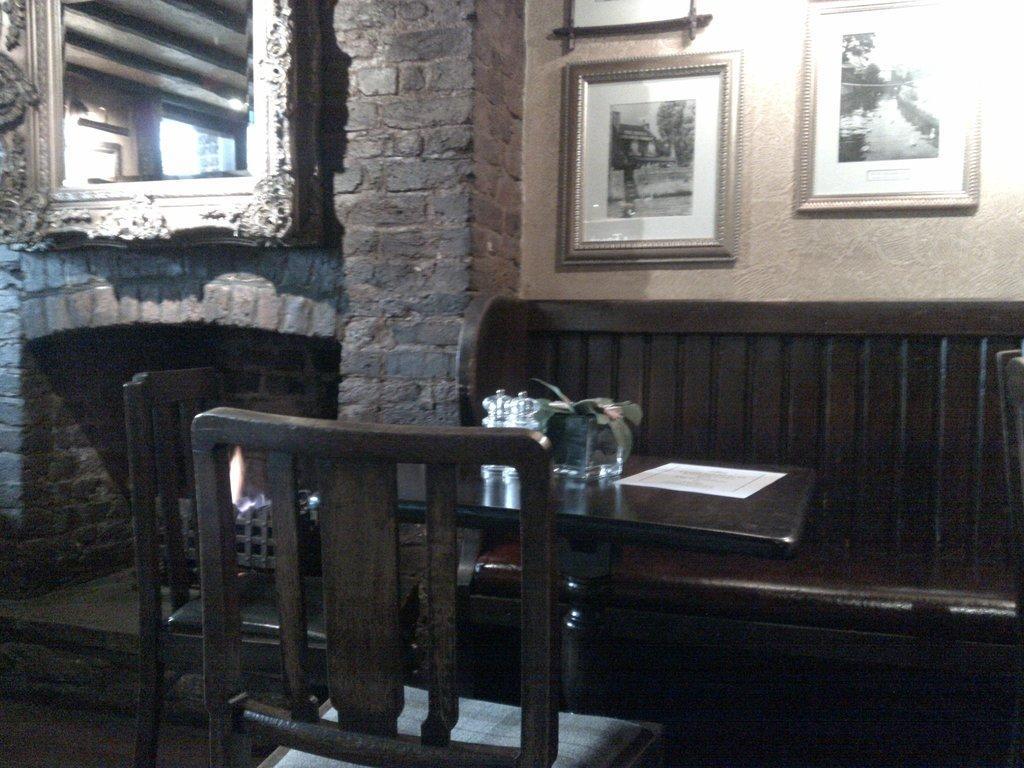How would you summarize this image in a sentence or two? Pictures on wall. This is a table and chairs. On table there is a plant, jar and paper. 